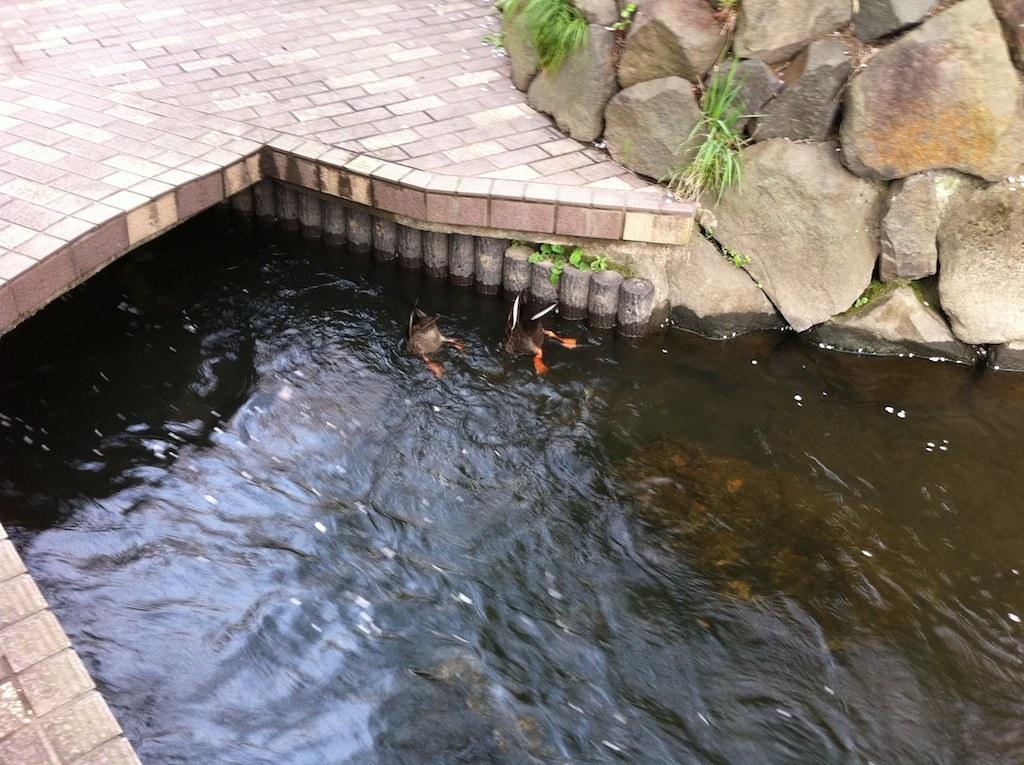Describe this image in one or two sentences. In this image, we can see few birds, in the water. Top of the image, we can see some stones, grass and walkway. 